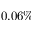Convert formula to latex. <formula><loc_0><loc_0><loc_500><loc_500>0 . 0 6 \%</formula> 